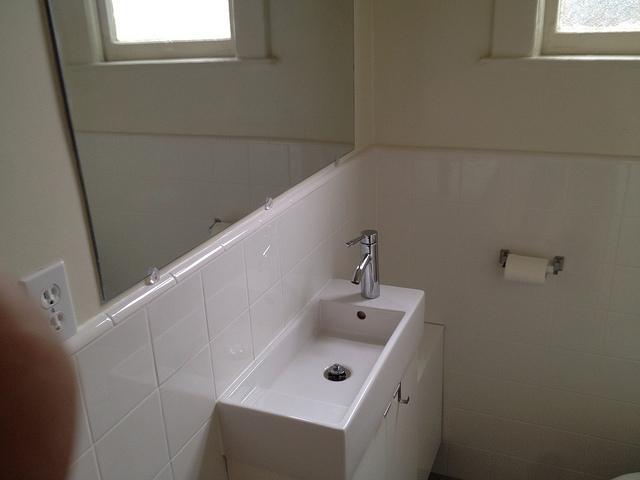How many outlets are there?
Give a very brief answer. 1. Is this roll of toilet paper new?
Concise answer only. No. Is the bathroom clean?
Short answer required. Yes. 